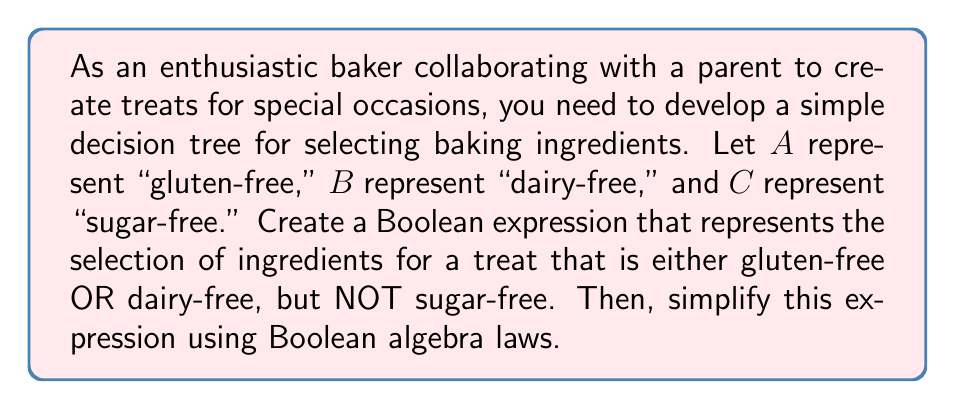Can you solve this math problem? Let's approach this step-by-step:

1) First, we need to translate the given conditions into a Boolean expression:
   - Either gluten-free OR dairy-free: $(A + B)$
   - NOT sugar-free: $\overline{C}$

2) Combining these conditions with AND, we get:
   $$(A + B) \cdot \overline{C}$$

3) Now, let's expand this expression using the distributive law:
   $$(A \cdot \overline{C}) + (B \cdot \overline{C})$$

4) This expression is already in its simplest form, as it represents:
   - (gluten-free AND not sugar-free) OR (dairy-free AND not sugar-free)

5) We can verify that this meets our requirements:
   - It allows for gluten-free or dairy-free options (or both)
   - It ensures the treat is not sugar-free

6) The decision tree based on this Boolean expression would have two main branches:
   - One for gluten-free options that are not sugar-free
   - One for dairy-free options that are not sugar-free

Therefore, the simplified Boolean expression $(A \cdot \overline{C}) + (B \cdot \overline{C})$ accurately represents our ingredient selection criteria.
Answer: $(A \cdot \overline{C}) + (B \cdot \overline{C})$ 